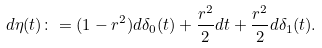Convert formula to latex. <formula><loc_0><loc_0><loc_500><loc_500>d \eta ( t ) \colon = ( 1 - r ^ { 2 } ) d \delta _ { 0 } ( t ) + \frac { r ^ { 2 } } { 2 } d t + \frac { r ^ { 2 } } { 2 } d \delta _ { 1 } ( t ) . \</formula> 